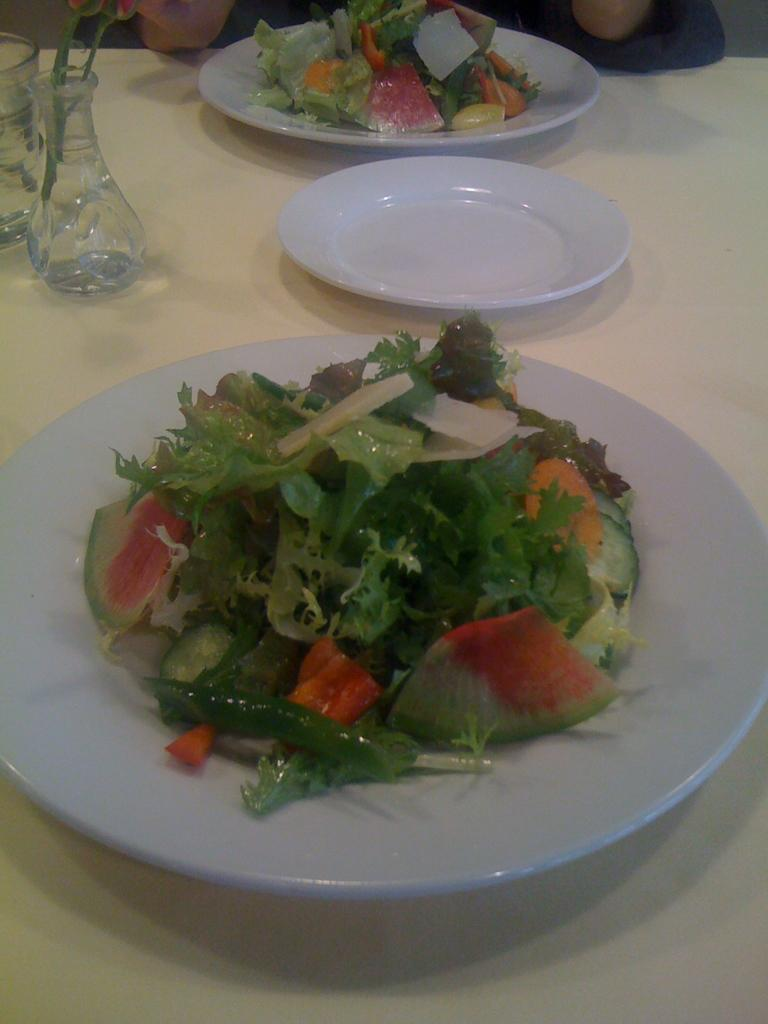What can be seen in the image that is typically used for drinking? There is a glass in the image. What is in the vase that is visible in the image? There is a vase with flowers in the image. What is on the surface that might be used for serving food? There are plates on a surface in the image. What type of food is on the plates in the image? There are salads on two plates in the image. Can you describe the person visible in the background of the image? There is a person visible in the background of the image, but no specific details are provided about their appearance or actions. What type of loaf is being baked in the oven in the image? There is no oven or loaf present in the image. How many bubbles can be seen floating around the person in the background? There are no bubbles visible in the image, and the person in the background is not interacting with any bubbles. 